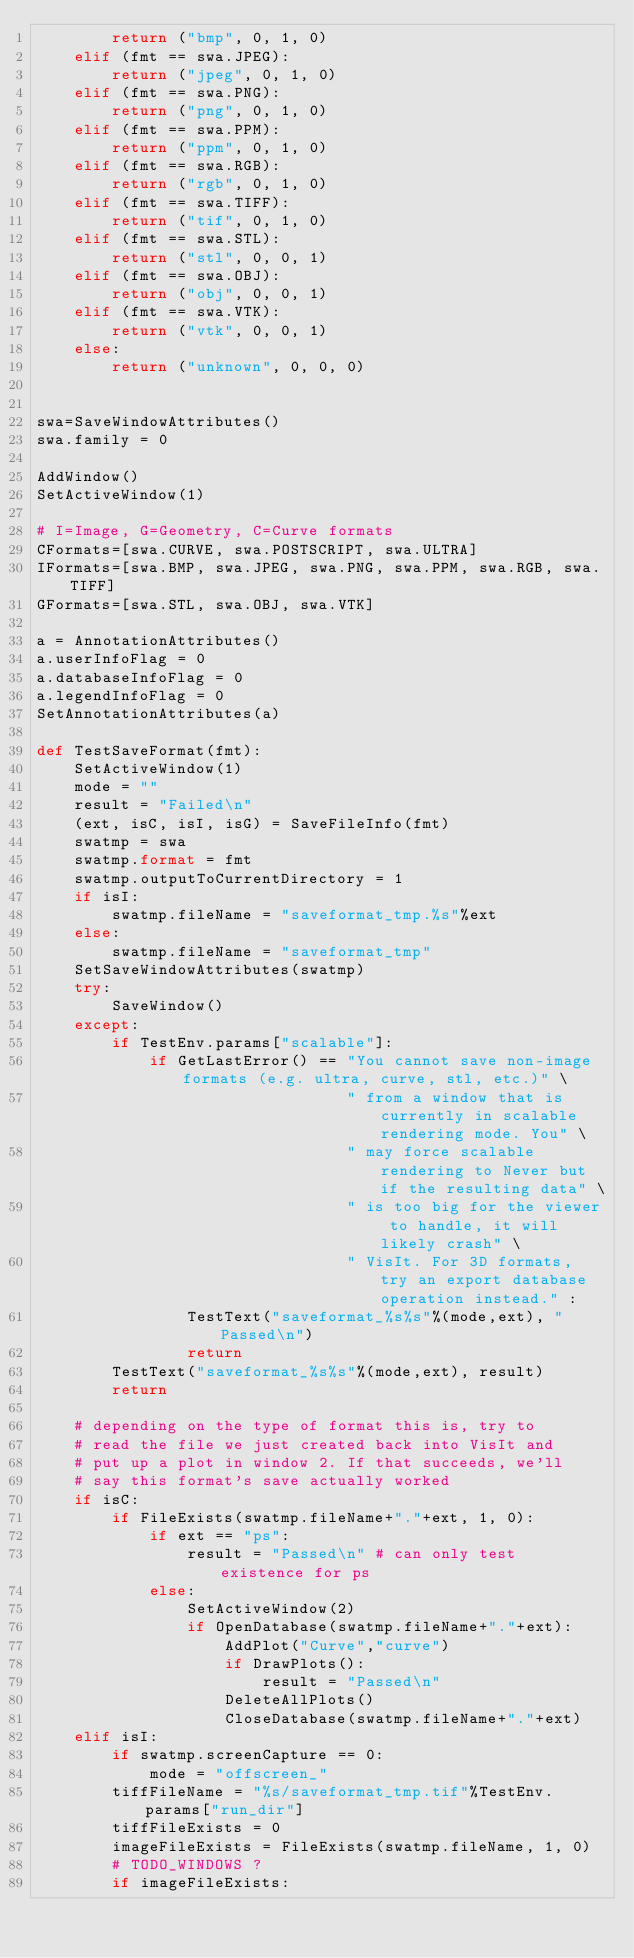<code> <loc_0><loc_0><loc_500><loc_500><_Python_>        return ("bmp", 0, 1, 0)
    elif (fmt == swa.JPEG):
        return ("jpeg", 0, 1, 0)
    elif (fmt == swa.PNG):
        return ("png", 0, 1, 0)
    elif (fmt == swa.PPM):
        return ("ppm", 0, 1, 0)
    elif (fmt == swa.RGB):
        return ("rgb", 0, 1, 0)
    elif (fmt == swa.TIFF):
        return ("tif", 0, 1, 0)
    elif (fmt == swa.STL):
        return ("stl", 0, 0, 1)
    elif (fmt == swa.OBJ):
        return ("obj", 0, 0, 1)
    elif (fmt == swa.VTK):
        return ("vtk", 0, 0, 1)
    else:
        return ("unknown", 0, 0, 0)


swa=SaveWindowAttributes()
swa.family = 0

AddWindow()
SetActiveWindow(1)

# I=Image, G=Geometry, C=Curve formats
CFormats=[swa.CURVE, swa.POSTSCRIPT, swa.ULTRA]
IFormats=[swa.BMP, swa.JPEG, swa.PNG, swa.PPM, swa.RGB, swa.TIFF]
GFormats=[swa.STL, swa.OBJ, swa.VTK]

a = AnnotationAttributes()
a.userInfoFlag = 0
a.databaseInfoFlag = 0
a.legendInfoFlag = 0
SetAnnotationAttributes(a)

def TestSaveFormat(fmt):
    SetActiveWindow(1)
    mode = ""
    result = "Failed\n"
    (ext, isC, isI, isG) = SaveFileInfo(fmt)
    swatmp = swa
    swatmp.format = fmt
    swatmp.outputToCurrentDirectory = 1
    if isI:
        swatmp.fileName = "saveformat_tmp.%s"%ext
    else:
        swatmp.fileName = "saveformat_tmp"
    SetSaveWindowAttributes(swatmp)
    try:
        SaveWindow()
    except:
        if TestEnv.params["scalable"]:
            if GetLastError() == "You cannot save non-image formats (e.g. ultra, curve, stl, etc.)" \
                                 " from a window that is currently in scalable rendering mode. You" \
                                 " may force scalable rendering to Never but if the resulting data" \
                                 " is too big for the viewer to handle, it will likely crash" \
                                 " VisIt. For 3D formats, try an export database operation instead." :
                TestText("saveformat_%s%s"%(mode,ext), "Passed\n")
                return
        TestText("saveformat_%s%s"%(mode,ext), result)
        return

    # depending on the type of format this is, try to
    # read the file we just created back into VisIt and
    # put up a plot in window 2. If that succeeds, we'll
    # say this format's save actually worked
    if isC:
        if FileExists(swatmp.fileName+"."+ext, 1, 0):
            if ext == "ps":
                result = "Passed\n" # can only test existence for ps
            else:
                SetActiveWindow(2)
                if OpenDatabase(swatmp.fileName+"."+ext):
                    AddPlot("Curve","curve")
                    if DrawPlots():
                        result = "Passed\n"
                    DeleteAllPlots()
                    CloseDatabase(swatmp.fileName+"."+ext)
    elif isI:
        if swatmp.screenCapture == 0:
            mode = "offscreen_"
        tiffFileName = "%s/saveformat_tmp.tif"%TestEnv.params["run_dir"]
        tiffFileExists = 0
        imageFileExists = FileExists(swatmp.fileName, 1, 0)
        # TODO_WINDOWS ?
        if imageFileExists:</code> 